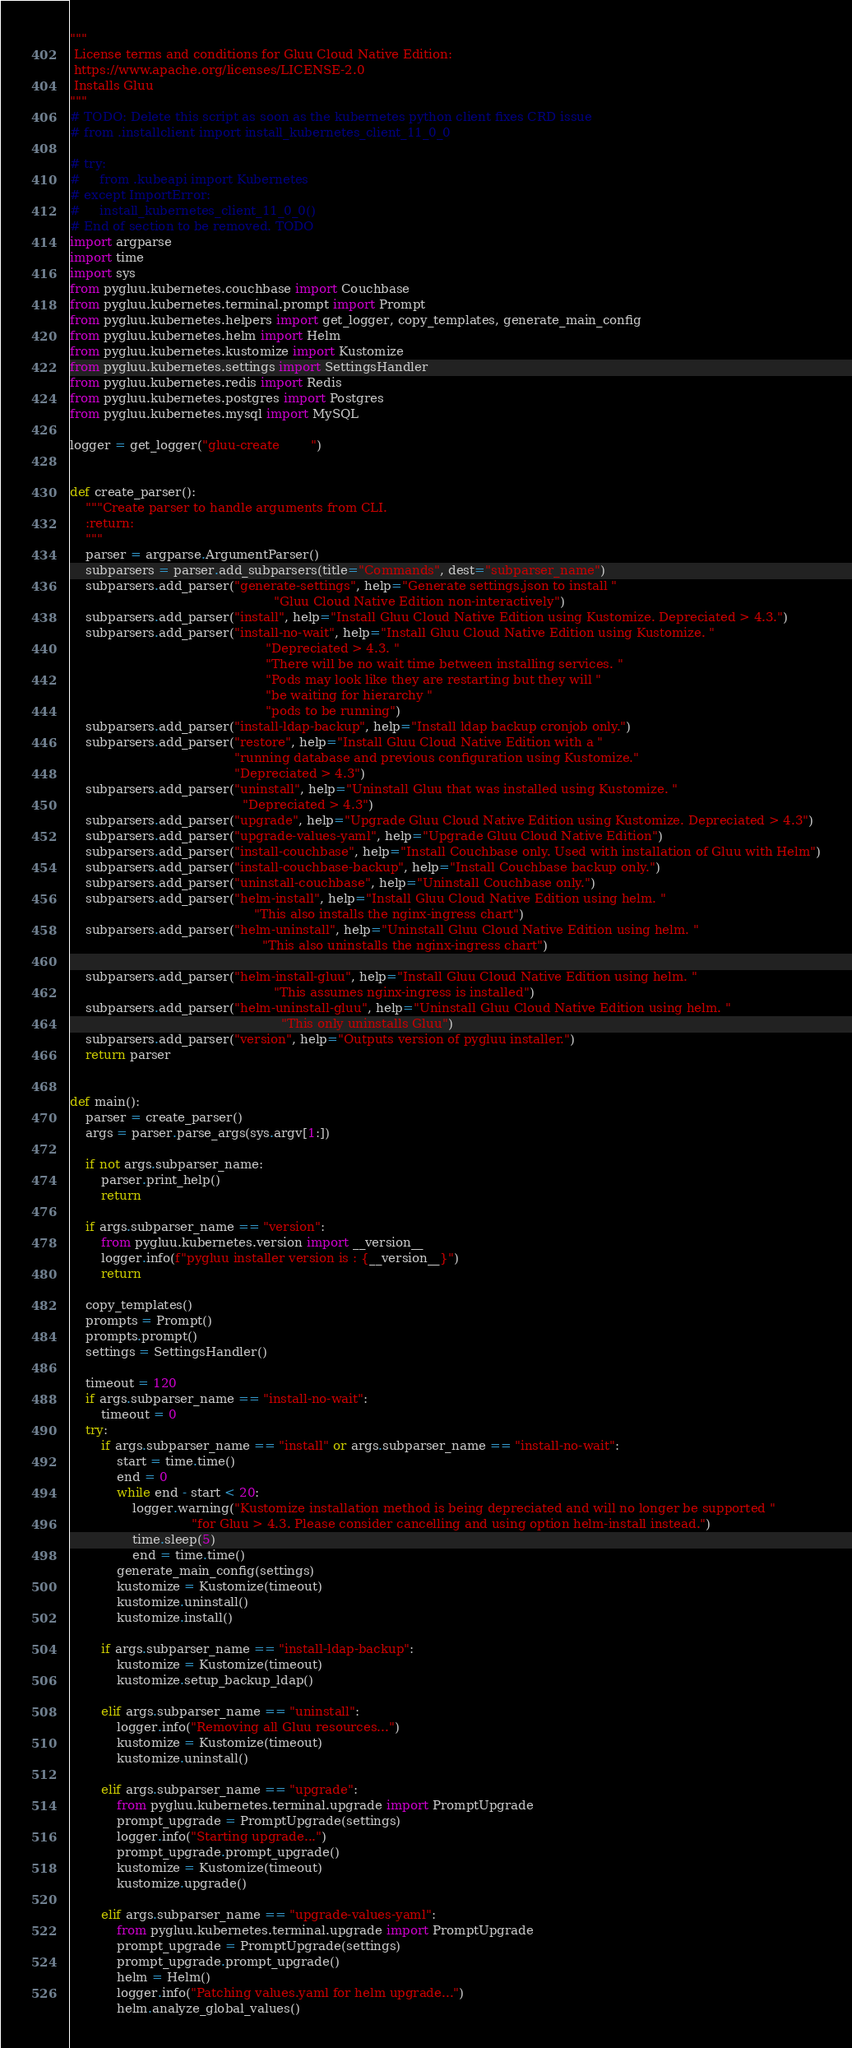<code> <loc_0><loc_0><loc_500><loc_500><_Python_>"""
 License terms and conditions for Gluu Cloud Native Edition:
 https://www.apache.org/licenses/LICENSE-2.0
 Installs Gluu
"""
# TODO: Delete this script as soon as the kubernetes python client fixes CRD issue
# from .installclient import install_kubernetes_client_11_0_0

# try:
#     from .kubeapi import Kubernetes
# except ImportError:
#     install_kubernetes_client_11_0_0()
# End of section to be removed. TODO
import argparse
import time
import sys
from pygluu.kubernetes.couchbase import Couchbase
from pygluu.kubernetes.terminal.prompt import Prompt
from pygluu.kubernetes.helpers import get_logger, copy_templates, generate_main_config
from pygluu.kubernetes.helm import Helm
from pygluu.kubernetes.kustomize import Kustomize
from pygluu.kubernetes.settings import SettingsHandler
from pygluu.kubernetes.redis import Redis
from pygluu.kubernetes.postgres import Postgres
from pygluu.kubernetes.mysql import MySQL

logger = get_logger("gluu-create        ")


def create_parser():
    """Create parser to handle arguments from CLI.
    :return:
    """
    parser = argparse.ArgumentParser()
    subparsers = parser.add_subparsers(title="Commands", dest="subparser_name")
    subparsers.add_parser("generate-settings", help="Generate settings.json to install "
                                                    "Gluu Cloud Native Edition non-interactively")
    subparsers.add_parser("install", help="Install Gluu Cloud Native Edition using Kustomize. Depreciated > 4.3.")
    subparsers.add_parser("install-no-wait", help="Install Gluu Cloud Native Edition using Kustomize. "
                                                  "Depreciated > 4.3. "
                                                  "There will be no wait time between installing services. "
                                                  "Pods may look like they are restarting but they will "
                                                  "be waiting for hierarchy "
                                                  "pods to be running")
    subparsers.add_parser("install-ldap-backup", help="Install ldap backup cronjob only.")
    subparsers.add_parser("restore", help="Install Gluu Cloud Native Edition with a "
                                          "running database and previous configuration using Kustomize."
                                          "Depreciated > 4.3")
    subparsers.add_parser("uninstall", help="Uninstall Gluu that was installed using Kustomize. "
                                            "Depreciated > 4.3")
    subparsers.add_parser("upgrade", help="Upgrade Gluu Cloud Native Edition using Kustomize. Depreciated > 4.3")
    subparsers.add_parser("upgrade-values-yaml", help="Upgrade Gluu Cloud Native Edition")
    subparsers.add_parser("install-couchbase", help="Install Couchbase only. Used with installation of Gluu with Helm")
    subparsers.add_parser("install-couchbase-backup", help="Install Couchbase backup only.")
    subparsers.add_parser("uninstall-couchbase", help="Uninstall Couchbase only.")
    subparsers.add_parser("helm-install", help="Install Gluu Cloud Native Edition using helm. "
                                               "This also installs the nginx-ingress chart")
    subparsers.add_parser("helm-uninstall", help="Uninstall Gluu Cloud Native Edition using helm. "
                                                 "This also uninstalls the nginx-ingress chart")

    subparsers.add_parser("helm-install-gluu", help="Install Gluu Cloud Native Edition using helm. "
                                                    "This assumes nginx-ingress is installed")
    subparsers.add_parser("helm-uninstall-gluu", help="Uninstall Gluu Cloud Native Edition using helm. "
                                                      "This only uninstalls Gluu")
    subparsers.add_parser("version", help="Outputs version of pygluu installer.")
    return parser


def main():
    parser = create_parser()
    args = parser.parse_args(sys.argv[1:])

    if not args.subparser_name:
        parser.print_help()
        return
    
    if args.subparser_name == "version":
        from pygluu.kubernetes.version import __version__
        logger.info(f"pygluu installer version is : {__version__}")
        return

    copy_templates()
    prompts = Prompt()
    prompts.prompt()
    settings = SettingsHandler()

    timeout = 120
    if args.subparser_name == "install-no-wait":
        timeout = 0
    try:
        if args.subparser_name == "install" or args.subparser_name == "install-no-wait":
            start = time.time()
            end = 0
            while end - start < 20:
                logger.warning("Kustomize installation method is being depreciated and will no longer be supported "
                               "for Gluu > 4.3. Please consider cancelling and using option helm-install instead.")
                time.sleep(5)
                end = time.time()
            generate_main_config(settings)
            kustomize = Kustomize(timeout)
            kustomize.uninstall()
            kustomize.install()

        if args.subparser_name == "install-ldap-backup":
            kustomize = Kustomize(timeout)
            kustomize.setup_backup_ldap()

        elif args.subparser_name == "uninstall":
            logger.info("Removing all Gluu resources...")
            kustomize = Kustomize(timeout)
            kustomize.uninstall()

        elif args.subparser_name == "upgrade":
            from pygluu.kubernetes.terminal.upgrade import PromptUpgrade
            prompt_upgrade = PromptUpgrade(settings)
            logger.info("Starting upgrade...")
            prompt_upgrade.prompt_upgrade()
            kustomize = Kustomize(timeout)
            kustomize.upgrade()

        elif args.subparser_name == "upgrade-values-yaml":
            from pygluu.kubernetes.terminal.upgrade import PromptUpgrade
            prompt_upgrade = PromptUpgrade(settings)
            prompt_upgrade.prompt_upgrade()
            helm = Helm()
            logger.info("Patching values.yaml for helm upgrade...")
            helm.analyze_global_values()</code> 